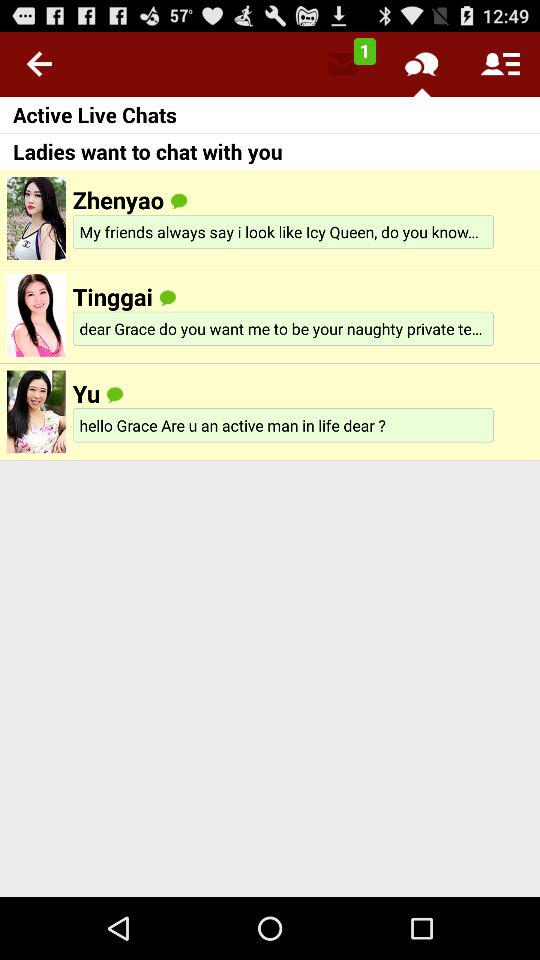Write the names of people who are active on live chats? The names are "Zhenyao", "Tinggai", and "Yu". 